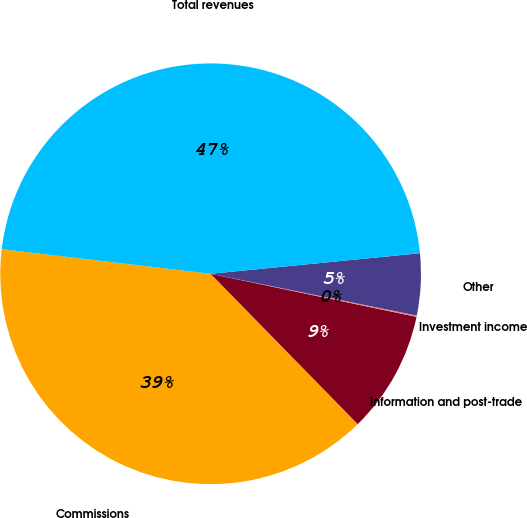<chart> <loc_0><loc_0><loc_500><loc_500><pie_chart><fcel>Commissions<fcel>Information and post-trade<fcel>Investment income<fcel>Other<fcel>Total revenues<nl><fcel>39.19%<fcel>9.39%<fcel>0.1%<fcel>4.74%<fcel>46.57%<nl></chart> 